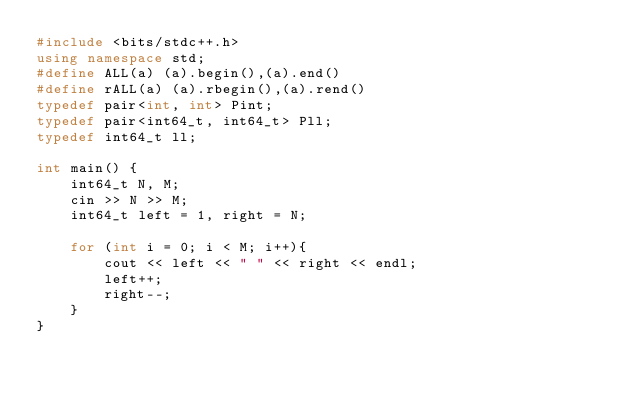<code> <loc_0><loc_0><loc_500><loc_500><_C++_>#include <bits/stdc++.h>
using namespace std;
#define ALL(a) (a).begin(),(a).end()
#define rALL(a) (a).rbegin(),(a).rend()
typedef pair<int, int> Pint;
typedef pair<int64_t, int64_t> Pll;
typedef int64_t ll;

int main() {
    int64_t N, M;
    cin >> N >> M;
    int64_t left = 1, right = N;

    for (int i = 0; i < M; i++){
        cout << left << " " << right << endl;
        left++;
        right--;
    }
}</code> 